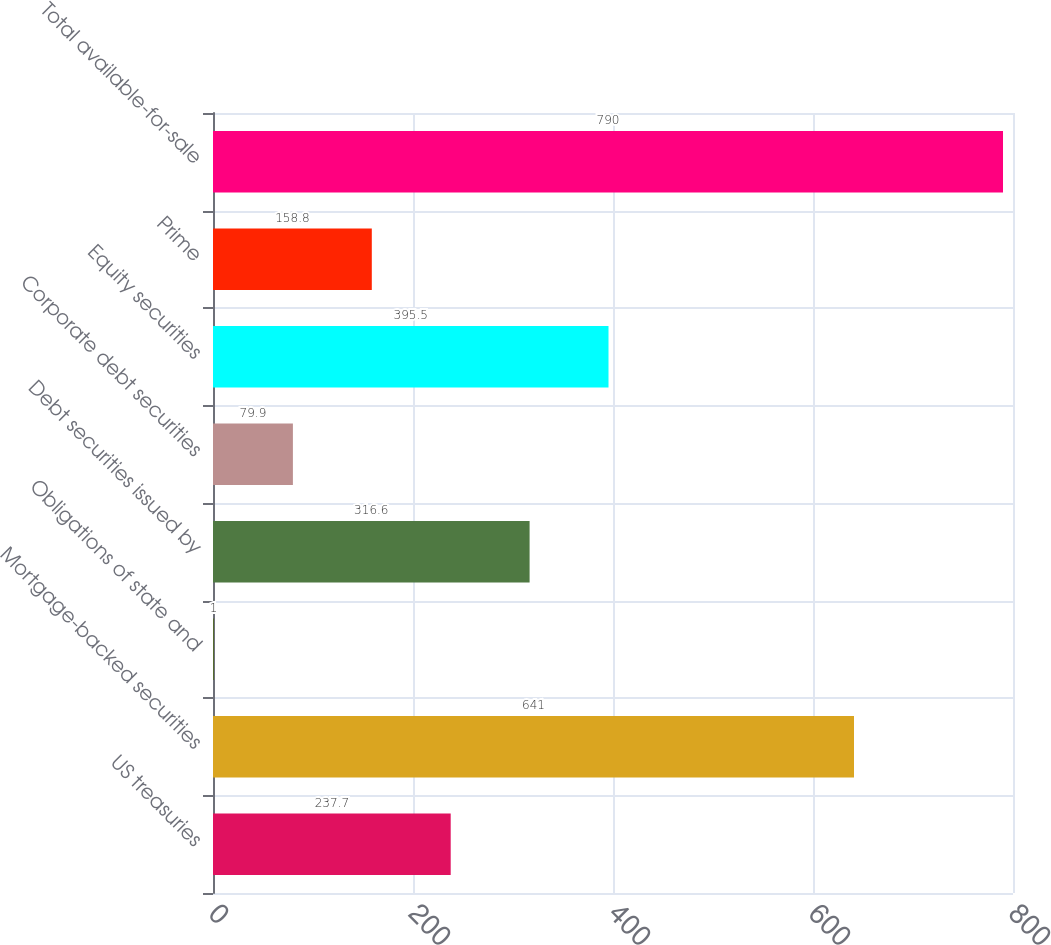Convert chart to OTSL. <chart><loc_0><loc_0><loc_500><loc_500><bar_chart><fcel>US treasuries<fcel>Mortgage-backed securities<fcel>Obligations of state and<fcel>Debt securities issued by<fcel>Corporate debt securities<fcel>Equity securities<fcel>Prime<fcel>Total available-for-sale<nl><fcel>237.7<fcel>641<fcel>1<fcel>316.6<fcel>79.9<fcel>395.5<fcel>158.8<fcel>790<nl></chart> 